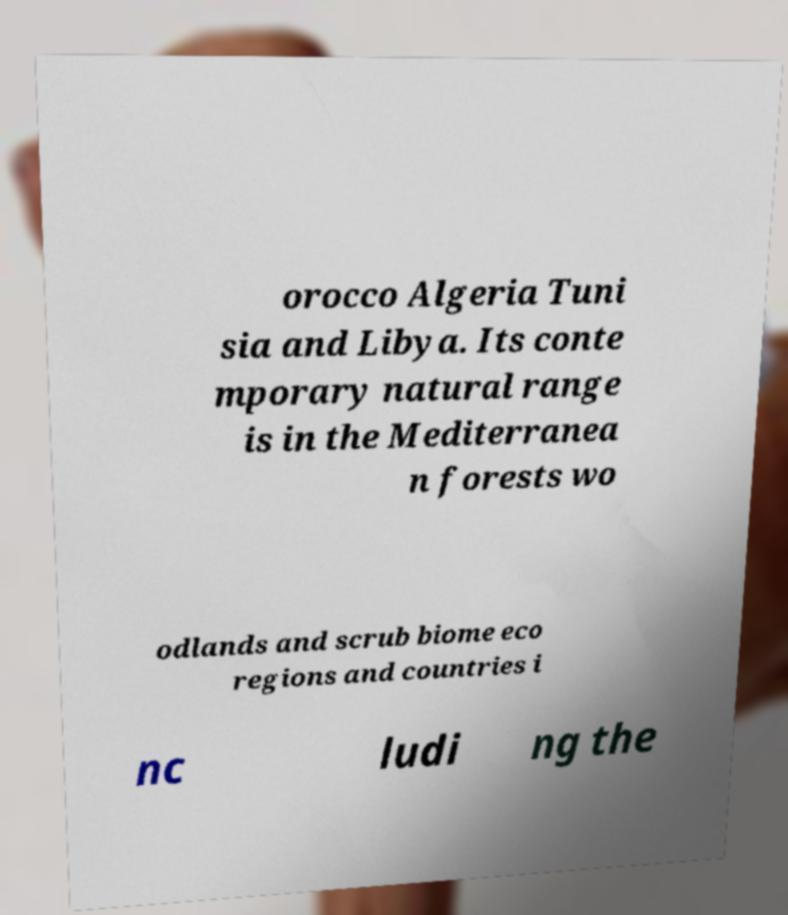For documentation purposes, I need the text within this image transcribed. Could you provide that? orocco Algeria Tuni sia and Libya. Its conte mporary natural range is in the Mediterranea n forests wo odlands and scrub biome eco regions and countries i nc ludi ng the 